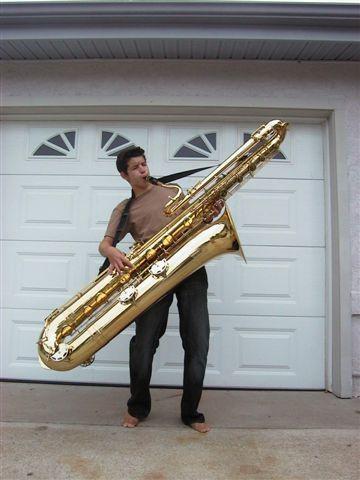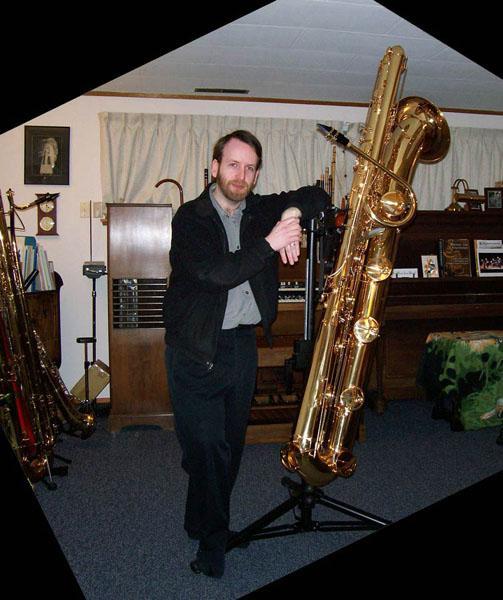The first image is the image on the left, the second image is the image on the right. Analyze the images presented: Is the assertion "In at least one  image there is a young man with a supersized saxophone tilted right and strapped to him while he is playing it." valid? Answer yes or no. Yes. The first image is the image on the left, the second image is the image on the right. Given the left and right images, does the statement "Each image shows a man with an oversized gold saxophone, and in at least one image, the saxophone is on a black stand." hold true? Answer yes or no. Yes. 